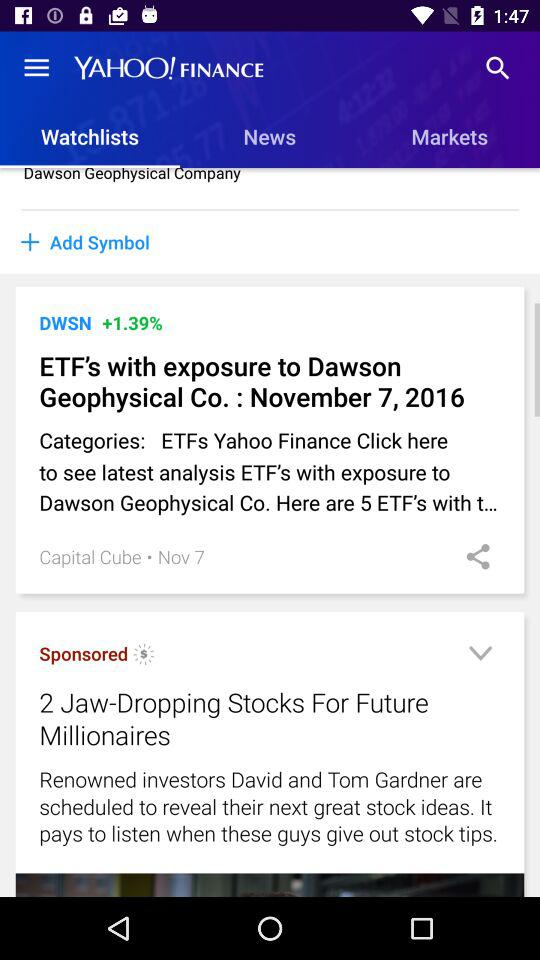What is the percentage increase in DWSN? There is an increase of 1.39% in DWSN. 